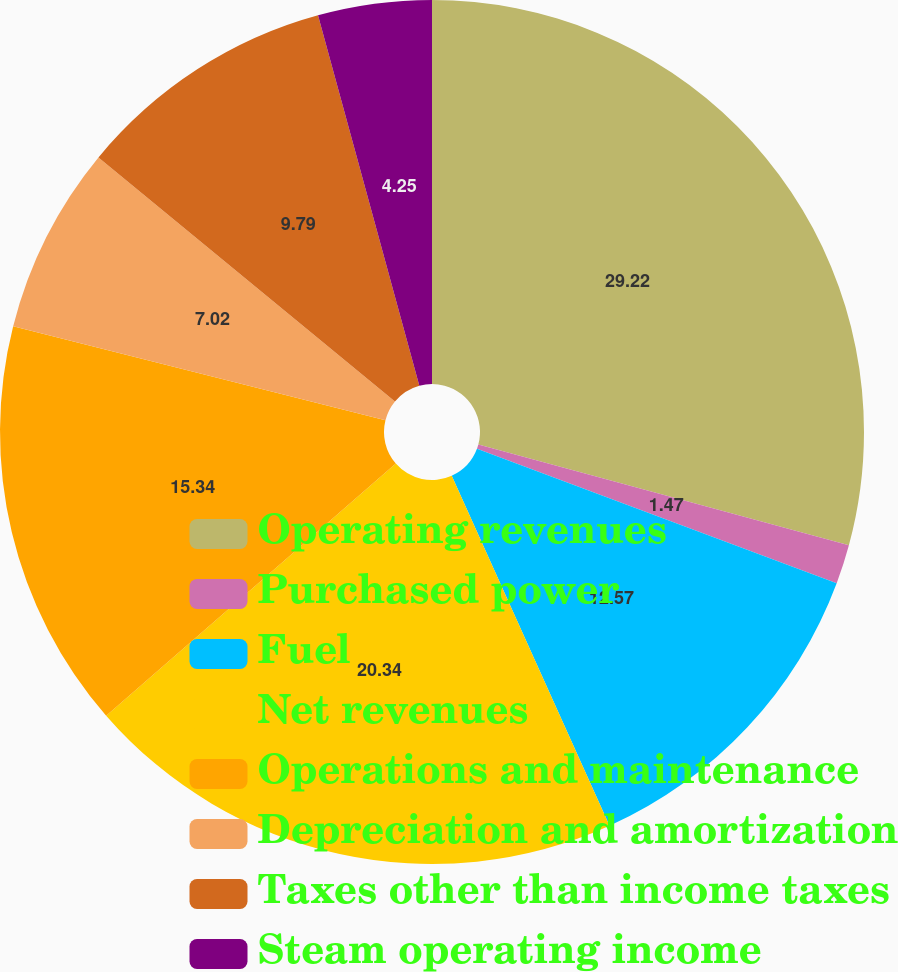Convert chart to OTSL. <chart><loc_0><loc_0><loc_500><loc_500><pie_chart><fcel>Operating revenues<fcel>Purchased power<fcel>Fuel<fcel>Net revenues<fcel>Operations and maintenance<fcel>Depreciation and amortization<fcel>Taxes other than income taxes<fcel>Steam operating income<nl><fcel>29.22%<fcel>1.47%<fcel>12.57%<fcel>20.34%<fcel>15.34%<fcel>7.02%<fcel>9.79%<fcel>4.25%<nl></chart> 